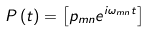<formula> <loc_0><loc_0><loc_500><loc_500>P \left ( t \right ) = \left [ p _ { m n } e ^ { i \omega _ { m n } t } \right ]</formula> 